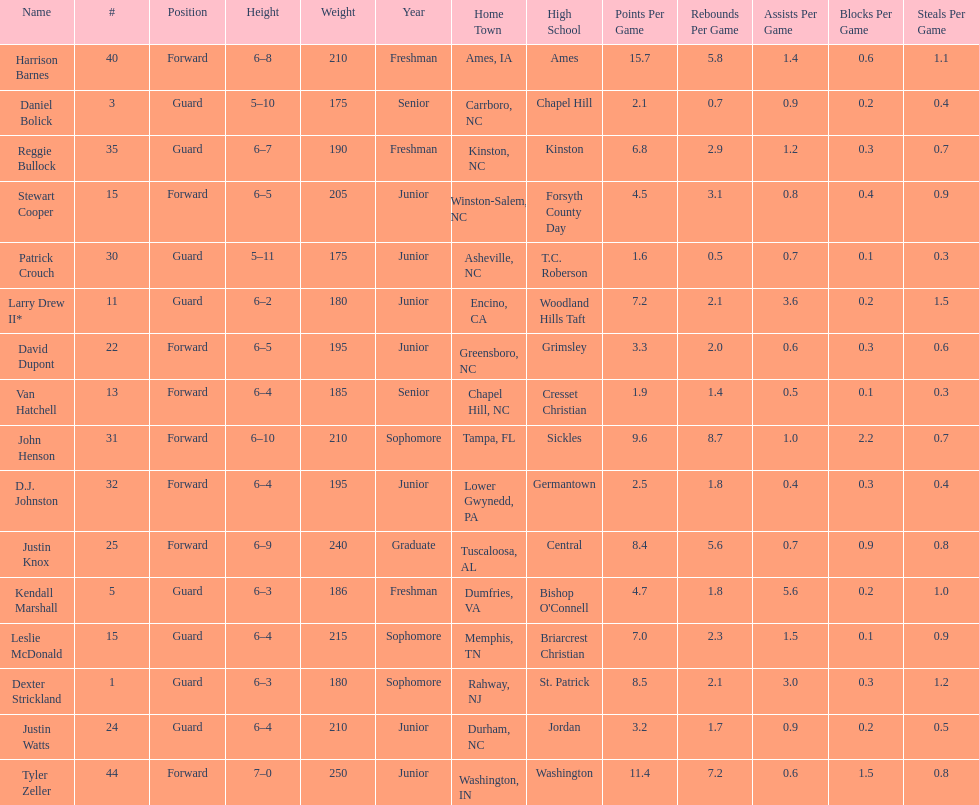Help me parse the entirety of this table. {'header': ['Name', '#', 'Position', 'Height', 'Weight', 'Year', 'Home Town', 'High School', 'Points Per Game', 'Rebounds Per Game', 'Assists Per Game', 'Blocks Per Game', 'Steals Per Game'], 'rows': [['Harrison Barnes', '40', 'Forward', '6–8', '210', 'Freshman', 'Ames, IA', 'Ames', '15.7', '5.8', '1.4', '0.6', '1.1'], ['Daniel Bolick', '3', 'Guard', '5–10', '175', 'Senior', 'Carrboro, NC', 'Chapel Hill', '2.1', '0.7', '0.9', '0.2', '0.4'], ['Reggie Bullock', '35', 'Guard', '6–7', '190', 'Freshman', 'Kinston, NC', 'Kinston', '6.8', '2.9', '1.2', '0.3', '0.7'], ['Stewart Cooper', '15', 'Forward', '6–5', '205', 'Junior', 'Winston-Salem, NC', 'Forsyth County Day', '4.5', '3.1', '0.8', '0.4', '0.9'], ['Patrick Crouch', '30', 'Guard', '5–11', '175', 'Junior', 'Asheville, NC', 'T.C. Roberson', '1.6', '0.5', '0.7', '0.1', '0.3'], ['Larry Drew II*', '11', 'Guard', '6–2', '180', 'Junior', 'Encino, CA', 'Woodland Hills Taft', '7.2', '2.1', '3.6', '0.2', '1.5'], ['David Dupont', '22', 'Forward', '6–5', '195', 'Junior', 'Greensboro, NC', 'Grimsley', '3.3', '2.0', '0.6', '0.3', '0.6'], ['Van Hatchell', '13', 'Forward', '6–4', '185', 'Senior', 'Chapel Hill, NC', 'Cresset Christian', '1.9', '1.4', '0.5', '0.1', '0.3'], ['John Henson', '31', 'Forward', '6–10', '210', 'Sophomore', 'Tampa, FL', 'Sickles', '9.6', '8.7', '1.0', '2.2', '0.7'], ['D.J. Johnston', '32', 'Forward', '6–4', '195', 'Junior', 'Lower Gwynedd, PA', 'Germantown', '2.5', '1.8', '0.4', '0.3', '0.4'], ['Justin Knox', '25', 'Forward', '6–9', '240', 'Graduate', 'Tuscaloosa, AL', 'Central', '8.4', '5.6', '0.7', '0.9', '0.8'], ['Kendall Marshall', '5', 'Guard', '6–3', '186', 'Freshman', 'Dumfries, VA', "Bishop O'Connell", '4.7', '1.8', '5.6', '0.2', '1.0'], ['Leslie McDonald', '15', 'Guard', '6–4', '215', 'Sophomore', 'Memphis, TN', 'Briarcrest Christian', '7.0', '2.3', '1.5', '0.1', '0.9'], ['Dexter Strickland', '1', 'Guard', '6–3', '180', 'Sophomore', 'Rahway, NJ', 'St. Patrick', '8.5', '2.1', '3.0', '0.3', '1.2'], ['Justin Watts', '24', 'Guard', '6–4', '210', 'Junior', 'Durham, NC', 'Jordan', '3.2', '1.7', '0.9', '0.2', '0.5'], ['Tyler Zeller', '44', 'Forward', '7–0', '250', 'Junior', 'Washington, IN', 'Washington', '11.4', '7.2', '0.6', '1.5', '0.8']]} Who was taller, justin knox or john henson? John Henson. 